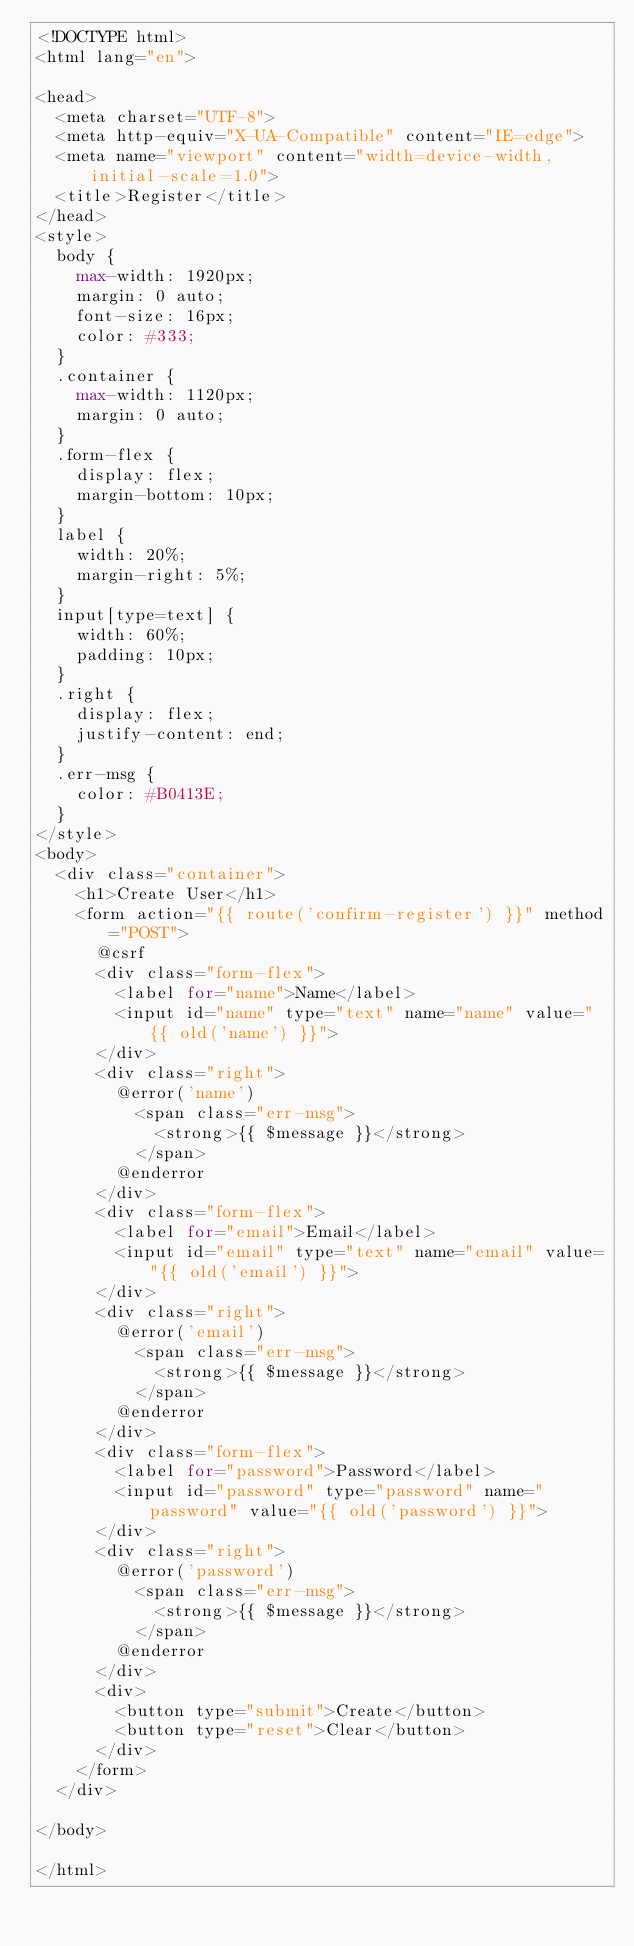Convert code to text. <code><loc_0><loc_0><loc_500><loc_500><_PHP_><!DOCTYPE html>
<html lang="en">

<head>
  <meta charset="UTF-8">
  <meta http-equiv="X-UA-Compatible" content="IE=edge">
  <meta name="viewport" content="width=device-width, initial-scale=1.0">
  <title>Register</title>
</head>
<style>
  body {
    max-width: 1920px;
    margin: 0 auto;
    font-size: 16px;
    color: #333;
  }
  .container {
    max-width: 1120px;
    margin: 0 auto;
  }
  .form-flex {
    display: flex;
    margin-bottom: 10px;
  }
  label {
    width: 20%;
    margin-right: 5%;
  }
  input[type=text] {
    width: 60%;
    padding: 10px;
  }
  .right {
    display: flex;
    justify-content: end;
  }
  .err-msg {
    color: #B0413E;
  }
</style>
<body>
  <div class="container">
    <h1>Create User</h1>
    <form action="{{ route('confirm-register') }}" method="POST">
      @csrf
      <div class="form-flex">
        <label for="name">Name</label>
        <input id="name" type="text" name="name" value="{{ old('name') }}">
      </div>
      <div class="right">
        @error('name')
          <span class="err-msg">
            <strong>{{ $message }}</strong>
          </span>
        @enderror
      </div>
      <div class="form-flex">
        <label for="email">Email</label>
        <input id="email" type="text" name="email" value="{{ old('email') }}">  
      </div>
      <div class="right">
        @error('email')
          <span class="err-msg">
            <strong>{{ $message }}</strong>
          </span>
        @enderror
      </div>
      <div class="form-flex">
        <label for="password">Password</label>
        <input id="password" type="password" name="password" value="{{ old('password') }}">  
      </div>
      <div class="right">
        @error('password')
          <span class="err-msg">
            <strong>{{ $message }}</strong>
          </span>
        @enderror
      </div>
      <div>
        <button type="submit">Create</button>
        <button type="reset">Clear</button>
      </div>
    </form>
  </div>

</body>

</html></code> 